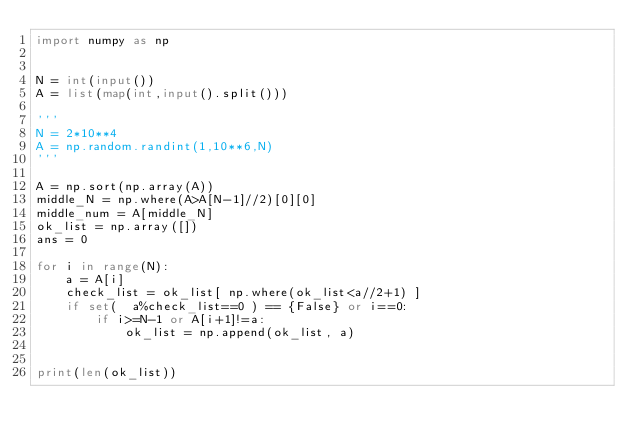<code> <loc_0><loc_0><loc_500><loc_500><_Python_>import numpy as np


N = int(input())
A = list(map(int,input().split()))

'''
N = 2*10**4
A = np.random.randint(1,10**6,N)
'''

A = np.sort(np.array(A))
middle_N = np.where(A>A[N-1]//2)[0][0]
middle_num = A[middle_N]
ok_list = np.array([])
ans = 0

for i in range(N):
    a = A[i]
    check_list = ok_list[ np.where(ok_list<a//2+1) ]
    if set(  a%check_list==0 ) == {False} or i==0:
        if i>=N-1 or A[i+1]!=a:
            ok_list = np.append(ok_list, a)


print(len(ok_list))
</code> 